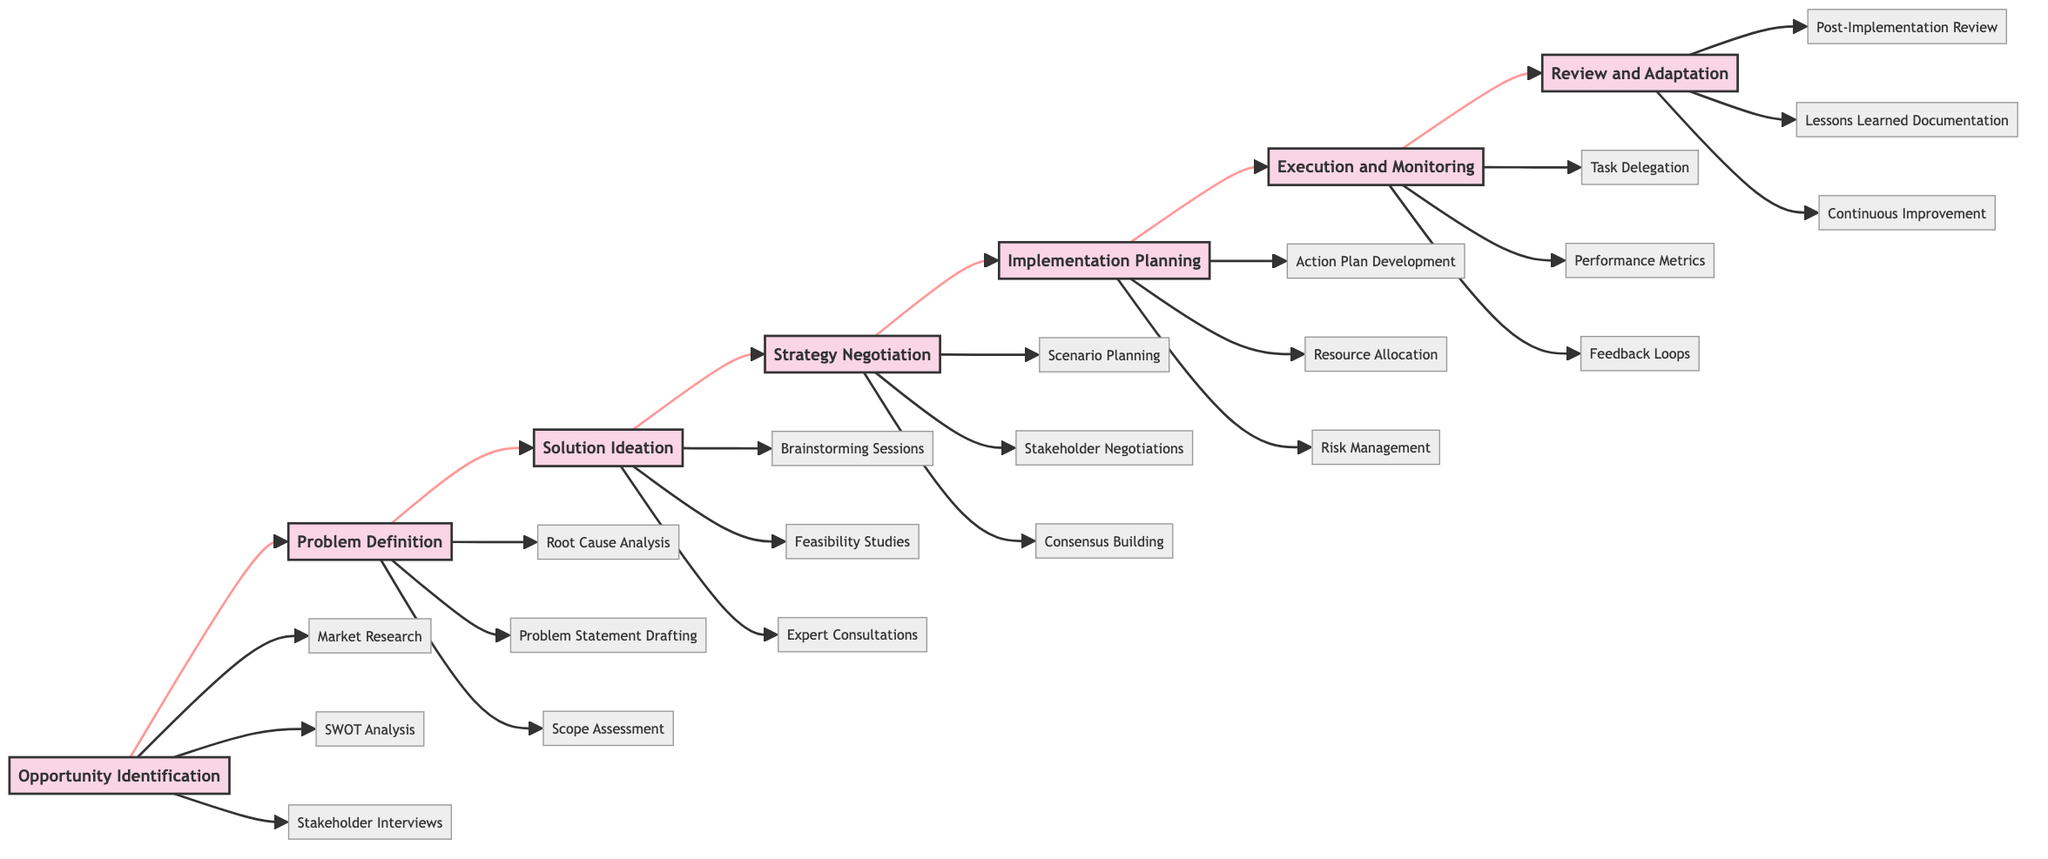What is the first phase in the diagram? The first phase is Opportunity Identification, which is the starting point of the horizontal flowchart. The flow starts at node A, listed as the first in the diagram.
Answer: Opportunity Identification How many key tasks are associated with Solution Ideation? There are three key tasks listed under Solution Ideation (node C): Brainstorming Sessions, Feasibility Studies, and Expert Consultations. Thus, the count is three.
Answer: 3 Which phase follows Implementation Planning? The phase that follows Implementation Planning (node E) is Execution and Monitoring (node F). This succession is direct and proceeds in a linear manner according to the diagram's flow.
Answer: Execution and Monitoring What key task is part of the Review and Adaptation phase? One of the key tasks listed for the Review and Adaptation phase (node G) is Post-Implementation Review. This is specified in the tasks branching from node G in the diagram.
Answer: Post-Implementation Review What describes the purpose of the Strategy Negotiation phase? The purpose of the Strategy Negotiation phase (node D) is to discuss and refine strategies. This purpose is succinctly stated in the description associated with that phase.
Answer: Discussing and refining strategies How many nodes represent phases in the diagram? There are seven distinct phases represented by nodes in the diagram: Opportunity Identification, Problem Definition, Solution Ideation, Strategy Negotiation, Implementation Planning, Execution and Monitoring, and Review and Adaptation. Thus, the count is seven.
Answer: 7 Which task is part of the Phase Problem Definition? A task that belongs to the Problem Definition phase (node B) is Root Cause Analysis. This task is one of three specified for that phase and it leads directly from node B.
Answer: Root Cause Analysis What is the last phase in the diagram? The last phase in the diagram is Review and Adaptation, which is the final node of the horizontal flow that concludes the process illustrated.
Answer: Review and Adaptation 